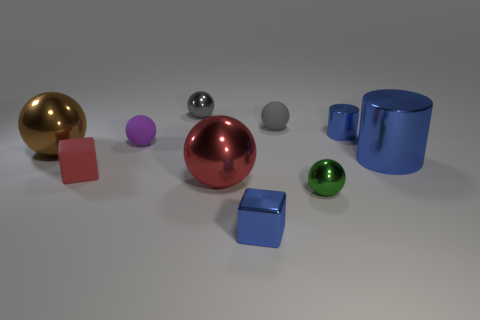There is a sphere to the left of the red rubber thing; does it have the same size as the tiny green metal sphere?
Offer a terse response. No. There is a brown thing that is the same shape as the small purple thing; what is it made of?
Your response must be concise. Metal. Does the small purple object have the same shape as the large brown metal thing?
Offer a terse response. Yes. There is a cylinder in front of the small blue cylinder; how many small blue cylinders are on the left side of it?
Make the answer very short. 1. What is the shape of the large red thing that is the same material as the tiny green thing?
Provide a succinct answer. Sphere. How many cyan objects are cylinders or big metal things?
Your answer should be very brief. 0. There is a small metal thing that is behind the blue object behind the small purple thing; is there a gray thing in front of it?
Make the answer very short. Yes. Are there fewer small cylinders than large blue metal blocks?
Provide a succinct answer. No. Does the metallic thing that is to the left of the red rubber block have the same shape as the gray shiny thing?
Your response must be concise. Yes. Are there any green matte spheres?
Your answer should be very brief. No. 